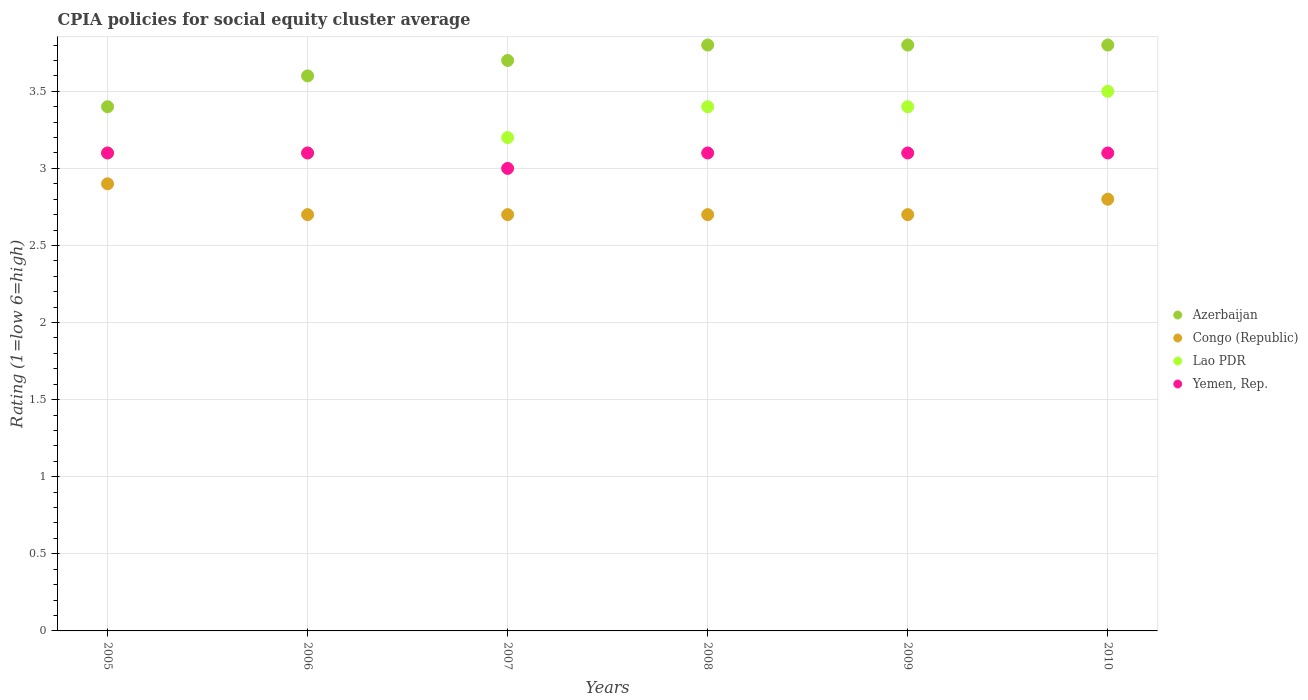Is the number of dotlines equal to the number of legend labels?
Make the answer very short. Yes. In which year was the CPIA rating in Lao PDR maximum?
Provide a succinct answer. 2010. In which year was the CPIA rating in Lao PDR minimum?
Give a very brief answer. 2005. What is the difference between the CPIA rating in Congo (Republic) in 2006 and the CPIA rating in Lao PDR in 2008?
Offer a very short reply. -0.7. What is the average CPIA rating in Lao PDR per year?
Offer a terse response. 3.28. In the year 2006, what is the difference between the CPIA rating in Congo (Republic) and CPIA rating in Lao PDR?
Offer a terse response. -0.4. In how many years, is the CPIA rating in Azerbaijan greater than 1.4?
Your answer should be compact. 6. What is the ratio of the CPIA rating in Congo (Republic) in 2005 to that in 2010?
Your answer should be very brief. 1.04. Is the CPIA rating in Azerbaijan in 2006 less than that in 2008?
Make the answer very short. Yes. Is the difference between the CPIA rating in Congo (Republic) in 2007 and 2009 greater than the difference between the CPIA rating in Lao PDR in 2007 and 2009?
Your response must be concise. Yes. What is the difference between the highest and the second highest CPIA rating in Azerbaijan?
Your answer should be compact. 0. What is the difference between the highest and the lowest CPIA rating in Congo (Republic)?
Make the answer very short. 0.2. In how many years, is the CPIA rating in Yemen, Rep. greater than the average CPIA rating in Yemen, Rep. taken over all years?
Your response must be concise. 5. Is the sum of the CPIA rating in Lao PDR in 2007 and 2010 greater than the maximum CPIA rating in Azerbaijan across all years?
Your answer should be compact. Yes. Is it the case that in every year, the sum of the CPIA rating in Lao PDR and CPIA rating in Congo (Republic)  is greater than the CPIA rating in Yemen, Rep.?
Keep it short and to the point. Yes. Is the CPIA rating in Yemen, Rep. strictly greater than the CPIA rating in Azerbaijan over the years?
Give a very brief answer. No. Is the CPIA rating in Yemen, Rep. strictly less than the CPIA rating in Azerbaijan over the years?
Keep it short and to the point. Yes. How many dotlines are there?
Offer a terse response. 4. How many years are there in the graph?
Provide a short and direct response. 6. Are the values on the major ticks of Y-axis written in scientific E-notation?
Offer a terse response. No. Does the graph contain any zero values?
Make the answer very short. No. Does the graph contain grids?
Your response must be concise. Yes. Where does the legend appear in the graph?
Provide a succinct answer. Center right. How are the legend labels stacked?
Your answer should be very brief. Vertical. What is the title of the graph?
Offer a very short reply. CPIA policies for social equity cluster average. Does "Tajikistan" appear as one of the legend labels in the graph?
Provide a succinct answer. No. What is the label or title of the Y-axis?
Offer a terse response. Rating (1=low 6=high). What is the Rating (1=low 6=high) in Congo (Republic) in 2005?
Your answer should be very brief. 2.9. What is the Rating (1=low 6=high) of Lao PDR in 2005?
Your response must be concise. 3.1. What is the Rating (1=low 6=high) in Yemen, Rep. in 2005?
Your response must be concise. 3.1. What is the Rating (1=low 6=high) of Congo (Republic) in 2006?
Keep it short and to the point. 2.7. What is the Rating (1=low 6=high) in Azerbaijan in 2007?
Your response must be concise. 3.7. What is the Rating (1=low 6=high) in Congo (Republic) in 2007?
Offer a terse response. 2.7. What is the Rating (1=low 6=high) in Lao PDR in 2007?
Keep it short and to the point. 3.2. What is the Rating (1=low 6=high) in Azerbaijan in 2008?
Your answer should be very brief. 3.8. What is the Rating (1=low 6=high) of Congo (Republic) in 2008?
Make the answer very short. 2.7. What is the Rating (1=low 6=high) of Azerbaijan in 2009?
Your answer should be very brief. 3.8. What is the Rating (1=low 6=high) of Congo (Republic) in 2009?
Provide a short and direct response. 2.7. What is the Rating (1=low 6=high) in Azerbaijan in 2010?
Keep it short and to the point. 3.8. What is the Rating (1=low 6=high) of Yemen, Rep. in 2010?
Your response must be concise. 3.1. Across all years, what is the maximum Rating (1=low 6=high) of Congo (Republic)?
Offer a very short reply. 2.9. Across all years, what is the maximum Rating (1=low 6=high) of Yemen, Rep.?
Offer a terse response. 3.1. Across all years, what is the minimum Rating (1=low 6=high) of Lao PDR?
Your response must be concise. 3.1. What is the total Rating (1=low 6=high) in Azerbaijan in the graph?
Provide a succinct answer. 22.1. What is the total Rating (1=low 6=high) of Lao PDR in the graph?
Provide a succinct answer. 19.7. What is the difference between the Rating (1=low 6=high) in Azerbaijan in 2005 and that in 2006?
Keep it short and to the point. -0.2. What is the difference between the Rating (1=low 6=high) in Congo (Republic) in 2005 and that in 2006?
Your response must be concise. 0.2. What is the difference between the Rating (1=low 6=high) in Lao PDR in 2005 and that in 2006?
Your answer should be very brief. 0. What is the difference between the Rating (1=low 6=high) in Azerbaijan in 2005 and that in 2007?
Your answer should be very brief. -0.3. What is the difference between the Rating (1=low 6=high) in Congo (Republic) in 2005 and that in 2007?
Offer a very short reply. 0.2. What is the difference between the Rating (1=low 6=high) in Lao PDR in 2005 and that in 2007?
Provide a short and direct response. -0.1. What is the difference between the Rating (1=low 6=high) of Yemen, Rep. in 2005 and that in 2007?
Give a very brief answer. 0.1. What is the difference between the Rating (1=low 6=high) in Congo (Republic) in 2005 and that in 2008?
Provide a succinct answer. 0.2. What is the difference between the Rating (1=low 6=high) in Lao PDR in 2005 and that in 2008?
Offer a terse response. -0.3. What is the difference between the Rating (1=low 6=high) in Yemen, Rep. in 2005 and that in 2008?
Keep it short and to the point. 0. What is the difference between the Rating (1=low 6=high) in Azerbaijan in 2005 and that in 2009?
Provide a short and direct response. -0.4. What is the difference between the Rating (1=low 6=high) in Congo (Republic) in 2005 and that in 2009?
Your answer should be compact. 0.2. What is the difference between the Rating (1=low 6=high) of Yemen, Rep. in 2005 and that in 2009?
Provide a short and direct response. 0. What is the difference between the Rating (1=low 6=high) in Congo (Republic) in 2005 and that in 2010?
Your response must be concise. 0.1. What is the difference between the Rating (1=low 6=high) of Lao PDR in 2005 and that in 2010?
Offer a terse response. -0.4. What is the difference between the Rating (1=low 6=high) of Yemen, Rep. in 2005 and that in 2010?
Your answer should be very brief. 0. What is the difference between the Rating (1=low 6=high) of Lao PDR in 2006 and that in 2007?
Offer a very short reply. -0.1. What is the difference between the Rating (1=low 6=high) in Congo (Republic) in 2006 and that in 2008?
Offer a very short reply. 0. What is the difference between the Rating (1=low 6=high) in Lao PDR in 2006 and that in 2008?
Provide a succinct answer. -0.3. What is the difference between the Rating (1=low 6=high) in Yemen, Rep. in 2006 and that in 2008?
Ensure brevity in your answer.  0. What is the difference between the Rating (1=low 6=high) in Azerbaijan in 2006 and that in 2009?
Your response must be concise. -0.2. What is the difference between the Rating (1=low 6=high) in Congo (Republic) in 2006 and that in 2009?
Give a very brief answer. 0. What is the difference between the Rating (1=low 6=high) of Lao PDR in 2006 and that in 2009?
Your answer should be compact. -0.3. What is the difference between the Rating (1=low 6=high) of Yemen, Rep. in 2006 and that in 2009?
Offer a very short reply. 0. What is the difference between the Rating (1=low 6=high) of Azerbaijan in 2006 and that in 2010?
Your answer should be very brief. -0.2. What is the difference between the Rating (1=low 6=high) of Lao PDR in 2006 and that in 2010?
Your response must be concise. -0.4. What is the difference between the Rating (1=low 6=high) in Azerbaijan in 2007 and that in 2008?
Ensure brevity in your answer.  -0.1. What is the difference between the Rating (1=low 6=high) in Congo (Republic) in 2007 and that in 2008?
Your response must be concise. 0. What is the difference between the Rating (1=low 6=high) in Congo (Republic) in 2007 and that in 2009?
Provide a succinct answer. 0. What is the difference between the Rating (1=low 6=high) in Lao PDR in 2007 and that in 2009?
Your response must be concise. -0.2. What is the difference between the Rating (1=low 6=high) of Yemen, Rep. in 2007 and that in 2009?
Keep it short and to the point. -0.1. What is the difference between the Rating (1=low 6=high) of Congo (Republic) in 2007 and that in 2010?
Ensure brevity in your answer.  -0.1. What is the difference between the Rating (1=low 6=high) in Yemen, Rep. in 2007 and that in 2010?
Your answer should be very brief. -0.1. What is the difference between the Rating (1=low 6=high) in Azerbaijan in 2008 and that in 2009?
Give a very brief answer. 0. What is the difference between the Rating (1=low 6=high) of Yemen, Rep. in 2008 and that in 2009?
Keep it short and to the point. 0. What is the difference between the Rating (1=low 6=high) in Azerbaijan in 2008 and that in 2010?
Your answer should be very brief. 0. What is the difference between the Rating (1=low 6=high) in Lao PDR in 2008 and that in 2010?
Keep it short and to the point. -0.1. What is the difference between the Rating (1=low 6=high) in Azerbaijan in 2009 and that in 2010?
Keep it short and to the point. 0. What is the difference between the Rating (1=low 6=high) of Yemen, Rep. in 2009 and that in 2010?
Ensure brevity in your answer.  0. What is the difference between the Rating (1=low 6=high) of Azerbaijan in 2005 and the Rating (1=low 6=high) of Yemen, Rep. in 2006?
Offer a very short reply. 0.3. What is the difference between the Rating (1=low 6=high) in Congo (Republic) in 2005 and the Rating (1=low 6=high) in Lao PDR in 2006?
Provide a succinct answer. -0.2. What is the difference between the Rating (1=low 6=high) of Azerbaijan in 2005 and the Rating (1=low 6=high) of Congo (Republic) in 2007?
Provide a succinct answer. 0.7. What is the difference between the Rating (1=low 6=high) of Azerbaijan in 2005 and the Rating (1=low 6=high) of Yemen, Rep. in 2007?
Provide a short and direct response. 0.4. What is the difference between the Rating (1=low 6=high) of Congo (Republic) in 2005 and the Rating (1=low 6=high) of Lao PDR in 2007?
Your response must be concise. -0.3. What is the difference between the Rating (1=low 6=high) of Congo (Republic) in 2005 and the Rating (1=low 6=high) of Yemen, Rep. in 2007?
Give a very brief answer. -0.1. What is the difference between the Rating (1=low 6=high) of Lao PDR in 2005 and the Rating (1=low 6=high) of Yemen, Rep. in 2007?
Provide a succinct answer. 0.1. What is the difference between the Rating (1=low 6=high) in Azerbaijan in 2005 and the Rating (1=low 6=high) in Congo (Republic) in 2008?
Provide a succinct answer. 0.7. What is the difference between the Rating (1=low 6=high) of Azerbaijan in 2005 and the Rating (1=low 6=high) of Lao PDR in 2008?
Offer a very short reply. 0. What is the difference between the Rating (1=low 6=high) of Congo (Republic) in 2005 and the Rating (1=low 6=high) of Lao PDR in 2008?
Make the answer very short. -0.5. What is the difference between the Rating (1=low 6=high) of Congo (Republic) in 2005 and the Rating (1=low 6=high) of Yemen, Rep. in 2008?
Offer a terse response. -0.2. What is the difference between the Rating (1=low 6=high) of Azerbaijan in 2005 and the Rating (1=low 6=high) of Congo (Republic) in 2009?
Offer a terse response. 0.7. What is the difference between the Rating (1=low 6=high) in Azerbaijan in 2005 and the Rating (1=low 6=high) in Lao PDR in 2009?
Your answer should be compact. 0. What is the difference between the Rating (1=low 6=high) in Azerbaijan in 2005 and the Rating (1=low 6=high) in Yemen, Rep. in 2009?
Offer a terse response. 0.3. What is the difference between the Rating (1=low 6=high) in Lao PDR in 2005 and the Rating (1=low 6=high) in Yemen, Rep. in 2009?
Provide a short and direct response. 0. What is the difference between the Rating (1=low 6=high) of Azerbaijan in 2005 and the Rating (1=low 6=high) of Congo (Republic) in 2010?
Keep it short and to the point. 0.6. What is the difference between the Rating (1=low 6=high) in Azerbaijan in 2005 and the Rating (1=low 6=high) in Yemen, Rep. in 2010?
Provide a short and direct response. 0.3. What is the difference between the Rating (1=low 6=high) in Congo (Republic) in 2005 and the Rating (1=low 6=high) in Lao PDR in 2010?
Offer a very short reply. -0.6. What is the difference between the Rating (1=low 6=high) in Congo (Republic) in 2005 and the Rating (1=low 6=high) in Yemen, Rep. in 2010?
Keep it short and to the point. -0.2. What is the difference between the Rating (1=low 6=high) of Azerbaijan in 2006 and the Rating (1=low 6=high) of Congo (Republic) in 2007?
Offer a very short reply. 0.9. What is the difference between the Rating (1=low 6=high) of Azerbaijan in 2006 and the Rating (1=low 6=high) of Yemen, Rep. in 2007?
Make the answer very short. 0.6. What is the difference between the Rating (1=low 6=high) in Congo (Republic) in 2006 and the Rating (1=low 6=high) in Lao PDR in 2007?
Ensure brevity in your answer.  -0.5. What is the difference between the Rating (1=low 6=high) of Azerbaijan in 2006 and the Rating (1=low 6=high) of Congo (Republic) in 2008?
Ensure brevity in your answer.  0.9. What is the difference between the Rating (1=low 6=high) of Azerbaijan in 2006 and the Rating (1=low 6=high) of Lao PDR in 2008?
Make the answer very short. 0.2. What is the difference between the Rating (1=low 6=high) in Congo (Republic) in 2006 and the Rating (1=low 6=high) in Lao PDR in 2008?
Offer a terse response. -0.7. What is the difference between the Rating (1=low 6=high) of Congo (Republic) in 2006 and the Rating (1=low 6=high) of Yemen, Rep. in 2008?
Ensure brevity in your answer.  -0.4. What is the difference between the Rating (1=low 6=high) of Lao PDR in 2006 and the Rating (1=low 6=high) of Yemen, Rep. in 2008?
Your answer should be very brief. 0. What is the difference between the Rating (1=low 6=high) of Azerbaijan in 2006 and the Rating (1=low 6=high) of Congo (Republic) in 2009?
Your response must be concise. 0.9. What is the difference between the Rating (1=low 6=high) in Azerbaijan in 2006 and the Rating (1=low 6=high) in Lao PDR in 2009?
Make the answer very short. 0.2. What is the difference between the Rating (1=low 6=high) of Congo (Republic) in 2006 and the Rating (1=low 6=high) of Yemen, Rep. in 2009?
Your response must be concise. -0.4. What is the difference between the Rating (1=low 6=high) of Lao PDR in 2006 and the Rating (1=low 6=high) of Yemen, Rep. in 2009?
Offer a very short reply. 0. What is the difference between the Rating (1=low 6=high) of Azerbaijan in 2006 and the Rating (1=low 6=high) of Congo (Republic) in 2010?
Offer a terse response. 0.8. What is the difference between the Rating (1=low 6=high) of Azerbaijan in 2006 and the Rating (1=low 6=high) of Yemen, Rep. in 2010?
Ensure brevity in your answer.  0.5. What is the difference between the Rating (1=low 6=high) in Azerbaijan in 2007 and the Rating (1=low 6=high) in Congo (Republic) in 2008?
Keep it short and to the point. 1. What is the difference between the Rating (1=low 6=high) in Azerbaijan in 2007 and the Rating (1=low 6=high) in Yemen, Rep. in 2008?
Give a very brief answer. 0.6. What is the difference between the Rating (1=low 6=high) in Azerbaijan in 2007 and the Rating (1=low 6=high) in Congo (Republic) in 2009?
Your answer should be very brief. 1. What is the difference between the Rating (1=low 6=high) of Congo (Republic) in 2007 and the Rating (1=low 6=high) of Lao PDR in 2009?
Your response must be concise. -0.7. What is the difference between the Rating (1=low 6=high) in Congo (Republic) in 2007 and the Rating (1=low 6=high) in Yemen, Rep. in 2009?
Offer a very short reply. -0.4. What is the difference between the Rating (1=low 6=high) of Azerbaijan in 2007 and the Rating (1=low 6=high) of Lao PDR in 2010?
Offer a terse response. 0.2. What is the difference between the Rating (1=low 6=high) of Azerbaijan in 2007 and the Rating (1=low 6=high) of Yemen, Rep. in 2010?
Provide a short and direct response. 0.6. What is the difference between the Rating (1=low 6=high) of Congo (Republic) in 2007 and the Rating (1=low 6=high) of Lao PDR in 2010?
Offer a very short reply. -0.8. What is the difference between the Rating (1=low 6=high) of Lao PDR in 2007 and the Rating (1=low 6=high) of Yemen, Rep. in 2010?
Provide a succinct answer. 0.1. What is the difference between the Rating (1=low 6=high) in Congo (Republic) in 2008 and the Rating (1=low 6=high) in Lao PDR in 2009?
Keep it short and to the point. -0.7. What is the difference between the Rating (1=low 6=high) of Azerbaijan in 2008 and the Rating (1=low 6=high) of Congo (Republic) in 2010?
Keep it short and to the point. 1. What is the difference between the Rating (1=low 6=high) in Azerbaijan in 2008 and the Rating (1=low 6=high) in Yemen, Rep. in 2010?
Your answer should be compact. 0.7. What is the difference between the Rating (1=low 6=high) in Azerbaijan in 2009 and the Rating (1=low 6=high) in Lao PDR in 2010?
Provide a succinct answer. 0.3. What is the difference between the Rating (1=low 6=high) in Congo (Republic) in 2009 and the Rating (1=low 6=high) in Yemen, Rep. in 2010?
Offer a terse response. -0.4. What is the difference between the Rating (1=low 6=high) of Lao PDR in 2009 and the Rating (1=low 6=high) of Yemen, Rep. in 2010?
Ensure brevity in your answer.  0.3. What is the average Rating (1=low 6=high) in Azerbaijan per year?
Offer a very short reply. 3.68. What is the average Rating (1=low 6=high) of Congo (Republic) per year?
Make the answer very short. 2.75. What is the average Rating (1=low 6=high) in Lao PDR per year?
Your answer should be compact. 3.28. What is the average Rating (1=low 6=high) of Yemen, Rep. per year?
Your answer should be compact. 3.08. In the year 2005, what is the difference between the Rating (1=low 6=high) of Azerbaijan and Rating (1=low 6=high) of Congo (Republic)?
Keep it short and to the point. 0.5. In the year 2005, what is the difference between the Rating (1=low 6=high) of Congo (Republic) and Rating (1=low 6=high) of Lao PDR?
Make the answer very short. -0.2. In the year 2005, what is the difference between the Rating (1=low 6=high) of Congo (Republic) and Rating (1=low 6=high) of Yemen, Rep.?
Give a very brief answer. -0.2. In the year 2005, what is the difference between the Rating (1=low 6=high) of Lao PDR and Rating (1=low 6=high) of Yemen, Rep.?
Ensure brevity in your answer.  0. In the year 2006, what is the difference between the Rating (1=low 6=high) of Azerbaijan and Rating (1=low 6=high) of Congo (Republic)?
Your response must be concise. 0.9. In the year 2007, what is the difference between the Rating (1=low 6=high) of Azerbaijan and Rating (1=low 6=high) of Congo (Republic)?
Offer a terse response. 1. In the year 2007, what is the difference between the Rating (1=low 6=high) of Congo (Republic) and Rating (1=low 6=high) of Lao PDR?
Ensure brevity in your answer.  -0.5. In the year 2007, what is the difference between the Rating (1=low 6=high) of Congo (Republic) and Rating (1=low 6=high) of Yemen, Rep.?
Your answer should be compact. -0.3. In the year 2007, what is the difference between the Rating (1=low 6=high) in Lao PDR and Rating (1=low 6=high) in Yemen, Rep.?
Your response must be concise. 0.2. In the year 2008, what is the difference between the Rating (1=low 6=high) of Azerbaijan and Rating (1=low 6=high) of Congo (Republic)?
Offer a terse response. 1.1. In the year 2008, what is the difference between the Rating (1=low 6=high) in Azerbaijan and Rating (1=low 6=high) in Lao PDR?
Make the answer very short. 0.4. In the year 2008, what is the difference between the Rating (1=low 6=high) of Congo (Republic) and Rating (1=low 6=high) of Lao PDR?
Your answer should be very brief. -0.7. In the year 2009, what is the difference between the Rating (1=low 6=high) of Azerbaijan and Rating (1=low 6=high) of Congo (Republic)?
Your answer should be very brief. 1.1. In the year 2010, what is the difference between the Rating (1=low 6=high) in Congo (Republic) and Rating (1=low 6=high) in Lao PDR?
Ensure brevity in your answer.  -0.7. What is the ratio of the Rating (1=low 6=high) in Azerbaijan in 2005 to that in 2006?
Provide a short and direct response. 0.94. What is the ratio of the Rating (1=low 6=high) of Congo (Republic) in 2005 to that in 2006?
Keep it short and to the point. 1.07. What is the ratio of the Rating (1=low 6=high) in Lao PDR in 2005 to that in 2006?
Make the answer very short. 1. What is the ratio of the Rating (1=low 6=high) of Yemen, Rep. in 2005 to that in 2006?
Your response must be concise. 1. What is the ratio of the Rating (1=low 6=high) of Azerbaijan in 2005 to that in 2007?
Offer a terse response. 0.92. What is the ratio of the Rating (1=low 6=high) of Congo (Republic) in 2005 to that in 2007?
Provide a short and direct response. 1.07. What is the ratio of the Rating (1=low 6=high) of Lao PDR in 2005 to that in 2007?
Offer a terse response. 0.97. What is the ratio of the Rating (1=low 6=high) in Yemen, Rep. in 2005 to that in 2007?
Provide a short and direct response. 1.03. What is the ratio of the Rating (1=low 6=high) in Azerbaijan in 2005 to that in 2008?
Make the answer very short. 0.89. What is the ratio of the Rating (1=low 6=high) of Congo (Republic) in 2005 to that in 2008?
Your answer should be very brief. 1.07. What is the ratio of the Rating (1=low 6=high) of Lao PDR in 2005 to that in 2008?
Offer a terse response. 0.91. What is the ratio of the Rating (1=low 6=high) of Azerbaijan in 2005 to that in 2009?
Provide a short and direct response. 0.89. What is the ratio of the Rating (1=low 6=high) of Congo (Republic) in 2005 to that in 2009?
Keep it short and to the point. 1.07. What is the ratio of the Rating (1=low 6=high) of Lao PDR in 2005 to that in 2009?
Offer a very short reply. 0.91. What is the ratio of the Rating (1=low 6=high) of Azerbaijan in 2005 to that in 2010?
Provide a short and direct response. 0.89. What is the ratio of the Rating (1=low 6=high) of Congo (Republic) in 2005 to that in 2010?
Offer a terse response. 1.04. What is the ratio of the Rating (1=low 6=high) in Lao PDR in 2005 to that in 2010?
Your response must be concise. 0.89. What is the ratio of the Rating (1=low 6=high) of Yemen, Rep. in 2005 to that in 2010?
Keep it short and to the point. 1. What is the ratio of the Rating (1=low 6=high) of Azerbaijan in 2006 to that in 2007?
Ensure brevity in your answer.  0.97. What is the ratio of the Rating (1=low 6=high) of Congo (Republic) in 2006 to that in 2007?
Provide a succinct answer. 1. What is the ratio of the Rating (1=low 6=high) in Lao PDR in 2006 to that in 2007?
Your response must be concise. 0.97. What is the ratio of the Rating (1=low 6=high) in Lao PDR in 2006 to that in 2008?
Ensure brevity in your answer.  0.91. What is the ratio of the Rating (1=low 6=high) of Azerbaijan in 2006 to that in 2009?
Your answer should be very brief. 0.95. What is the ratio of the Rating (1=low 6=high) in Lao PDR in 2006 to that in 2009?
Provide a succinct answer. 0.91. What is the ratio of the Rating (1=low 6=high) of Yemen, Rep. in 2006 to that in 2009?
Your answer should be very brief. 1. What is the ratio of the Rating (1=low 6=high) of Azerbaijan in 2006 to that in 2010?
Ensure brevity in your answer.  0.95. What is the ratio of the Rating (1=low 6=high) in Congo (Republic) in 2006 to that in 2010?
Make the answer very short. 0.96. What is the ratio of the Rating (1=low 6=high) of Lao PDR in 2006 to that in 2010?
Offer a terse response. 0.89. What is the ratio of the Rating (1=low 6=high) in Yemen, Rep. in 2006 to that in 2010?
Ensure brevity in your answer.  1. What is the ratio of the Rating (1=low 6=high) of Azerbaijan in 2007 to that in 2008?
Offer a very short reply. 0.97. What is the ratio of the Rating (1=low 6=high) in Congo (Republic) in 2007 to that in 2008?
Your response must be concise. 1. What is the ratio of the Rating (1=low 6=high) in Yemen, Rep. in 2007 to that in 2008?
Your response must be concise. 0.97. What is the ratio of the Rating (1=low 6=high) of Azerbaijan in 2007 to that in 2009?
Your answer should be very brief. 0.97. What is the ratio of the Rating (1=low 6=high) in Lao PDR in 2007 to that in 2009?
Your answer should be compact. 0.94. What is the ratio of the Rating (1=low 6=high) of Azerbaijan in 2007 to that in 2010?
Offer a very short reply. 0.97. What is the ratio of the Rating (1=low 6=high) of Lao PDR in 2007 to that in 2010?
Your response must be concise. 0.91. What is the ratio of the Rating (1=low 6=high) of Yemen, Rep. in 2007 to that in 2010?
Your answer should be very brief. 0.97. What is the ratio of the Rating (1=low 6=high) of Azerbaijan in 2008 to that in 2009?
Your answer should be compact. 1. What is the ratio of the Rating (1=low 6=high) in Congo (Republic) in 2008 to that in 2009?
Give a very brief answer. 1. What is the ratio of the Rating (1=low 6=high) of Yemen, Rep. in 2008 to that in 2009?
Provide a short and direct response. 1. What is the ratio of the Rating (1=low 6=high) in Congo (Republic) in 2008 to that in 2010?
Make the answer very short. 0.96. What is the ratio of the Rating (1=low 6=high) in Lao PDR in 2008 to that in 2010?
Make the answer very short. 0.97. What is the ratio of the Rating (1=low 6=high) of Azerbaijan in 2009 to that in 2010?
Offer a very short reply. 1. What is the ratio of the Rating (1=low 6=high) of Congo (Republic) in 2009 to that in 2010?
Your answer should be compact. 0.96. What is the ratio of the Rating (1=low 6=high) in Lao PDR in 2009 to that in 2010?
Keep it short and to the point. 0.97. What is the ratio of the Rating (1=low 6=high) of Yemen, Rep. in 2009 to that in 2010?
Offer a very short reply. 1. What is the difference between the highest and the second highest Rating (1=low 6=high) in Azerbaijan?
Offer a terse response. 0. What is the difference between the highest and the second highest Rating (1=low 6=high) in Congo (Republic)?
Your answer should be very brief. 0.1. What is the difference between the highest and the second highest Rating (1=low 6=high) in Lao PDR?
Make the answer very short. 0.1. What is the difference between the highest and the second highest Rating (1=low 6=high) in Yemen, Rep.?
Make the answer very short. 0. What is the difference between the highest and the lowest Rating (1=low 6=high) of Lao PDR?
Offer a terse response. 0.4. 